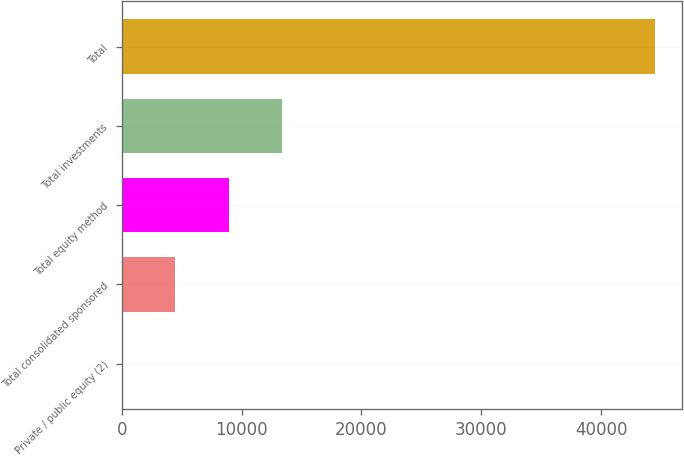<chart> <loc_0><loc_0><loc_500><loc_500><bar_chart><fcel>Private / public equity (2)<fcel>Total consolidated sponsored<fcel>Total equity method<fcel>Total investments<fcel>Total<nl><fcel>13<fcel>4462.8<fcel>8912.6<fcel>13362.4<fcel>44511<nl></chart> 